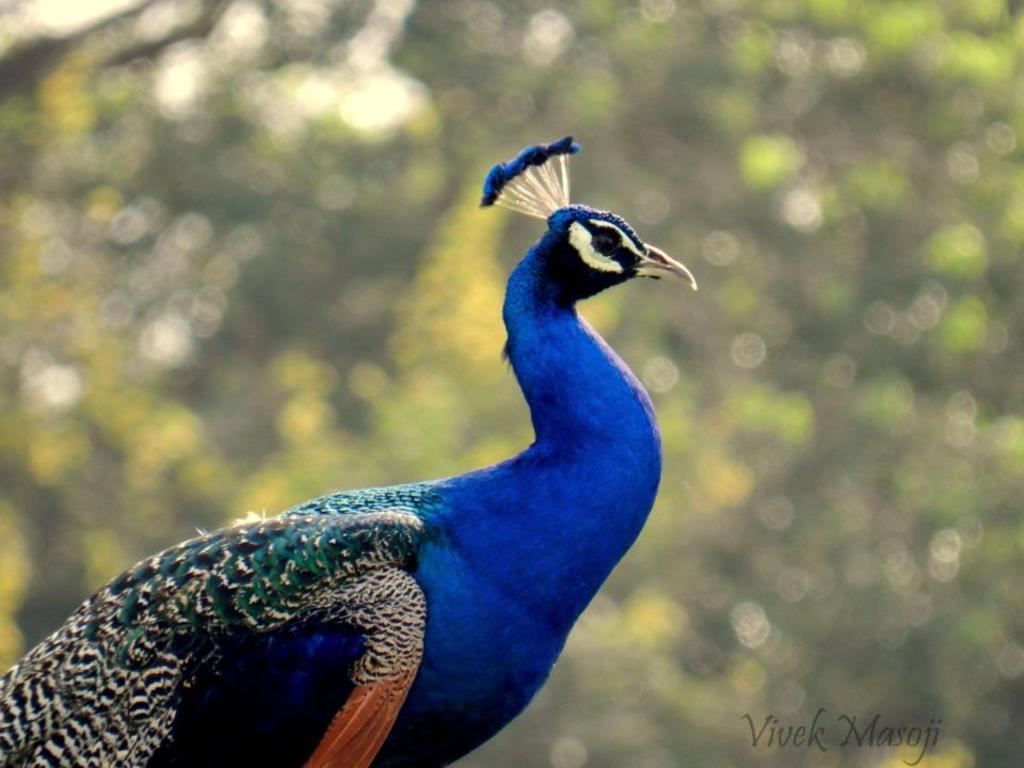Describe this image in one or two sentences. This image consists of a peacock in blue color. In the background, we can see the trees. And the background is blurred. 